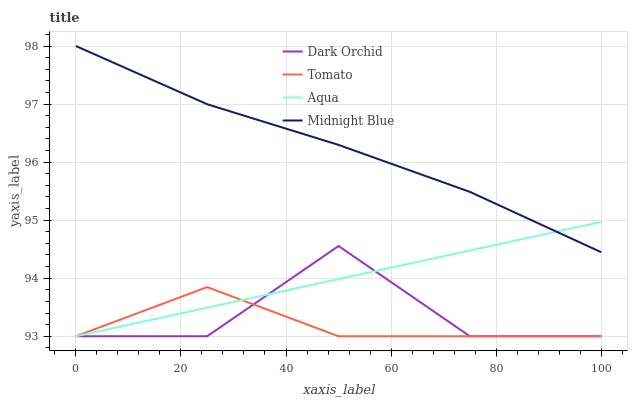Does Tomato have the minimum area under the curve?
Answer yes or no. Yes. Does Midnight Blue have the maximum area under the curve?
Answer yes or no. Yes. Does Aqua have the minimum area under the curve?
Answer yes or no. No. Does Aqua have the maximum area under the curve?
Answer yes or no. No. Is Aqua the smoothest?
Answer yes or no. Yes. Is Dark Orchid the roughest?
Answer yes or no. Yes. Is Midnight Blue the smoothest?
Answer yes or no. No. Is Midnight Blue the roughest?
Answer yes or no. No. Does Tomato have the lowest value?
Answer yes or no. Yes. Does Midnight Blue have the lowest value?
Answer yes or no. No. Does Midnight Blue have the highest value?
Answer yes or no. Yes. Does Aqua have the highest value?
Answer yes or no. No. Is Tomato less than Midnight Blue?
Answer yes or no. Yes. Is Midnight Blue greater than Tomato?
Answer yes or no. Yes. Does Aqua intersect Midnight Blue?
Answer yes or no. Yes. Is Aqua less than Midnight Blue?
Answer yes or no. No. Is Aqua greater than Midnight Blue?
Answer yes or no. No. Does Tomato intersect Midnight Blue?
Answer yes or no. No. 